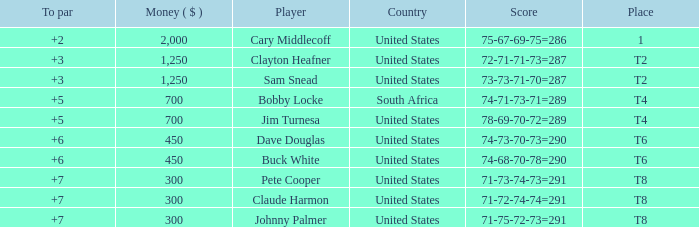What Country is Player Sam Snead with a To par of less than 5 from? United States. 